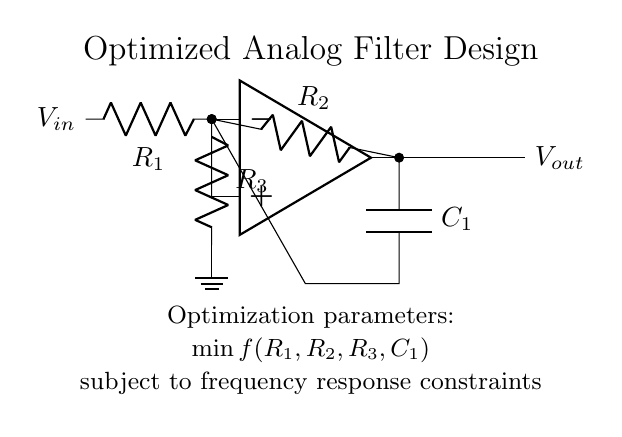What is the type of amplifier used in this circuit? The circuit uses an operational amplifier, identified by the op amp symbol in the diagram.
Answer: Operational amplifier What is the function of the capacitor in this circuit? The capacitor acts as a coupling element to allow AC signals to pass while blocking DC, which is essential for filtering applications.
Answer: Coupling How many resistors are present in the circuit? Upon inspecting the diagram, three resistors are labeled, which are R1, R2, and R3.
Answer: Three What is the output voltage relationship in this circuit? The output voltage is influenced by the arrangement of components around the operational amplifier as well as the resistances and capacitance values. Specifically, it involves the feedback from R2 and the input parameter.
Answer: Dependent on feedback What is being minimized in the optimization process? The optimization focuses on minimizing a function represented by the parameters R1, R2, R3, and C1 under specific frequency constraints, which help achieve desired filter characteristics.
Answer: Function minimization What is the role of R3 in the circuit? Resistor R3 is connected to the non-inverting terminal of the operational amplifier, establishing a relationship with the input voltage and influencing gain and stability of the circuit.
Answer: Gain and stability influence 